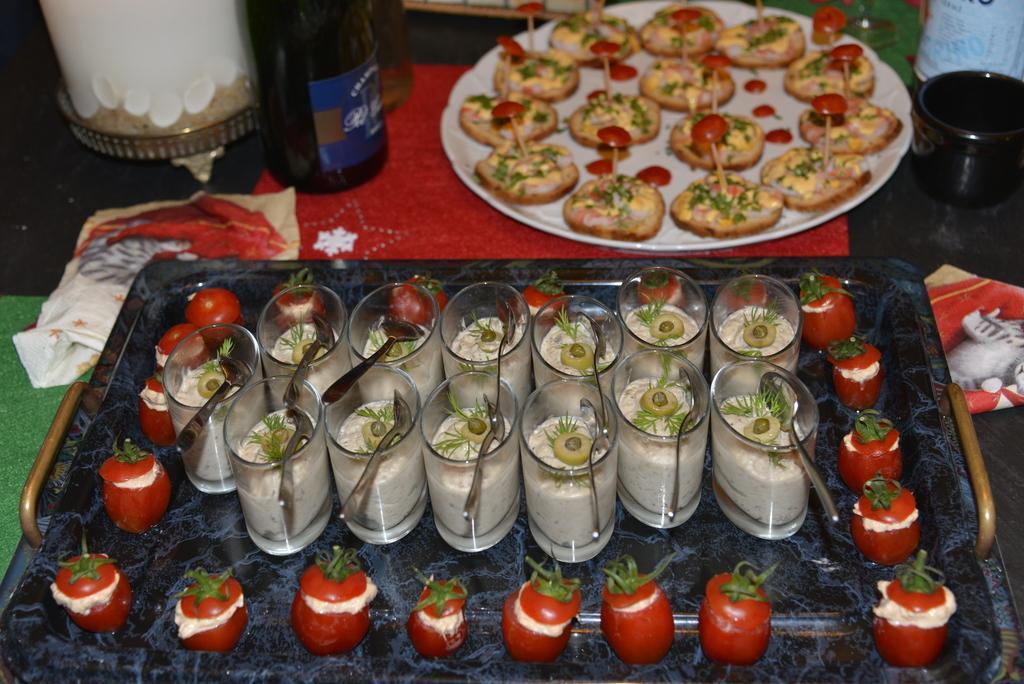Can you describe this image briefly? In this image we can see some food in the plate. We can also see some spoons in the glasses and some tomatoes which are placed in a tray, some napkins, a bottle and a glass which are placed on the table. 